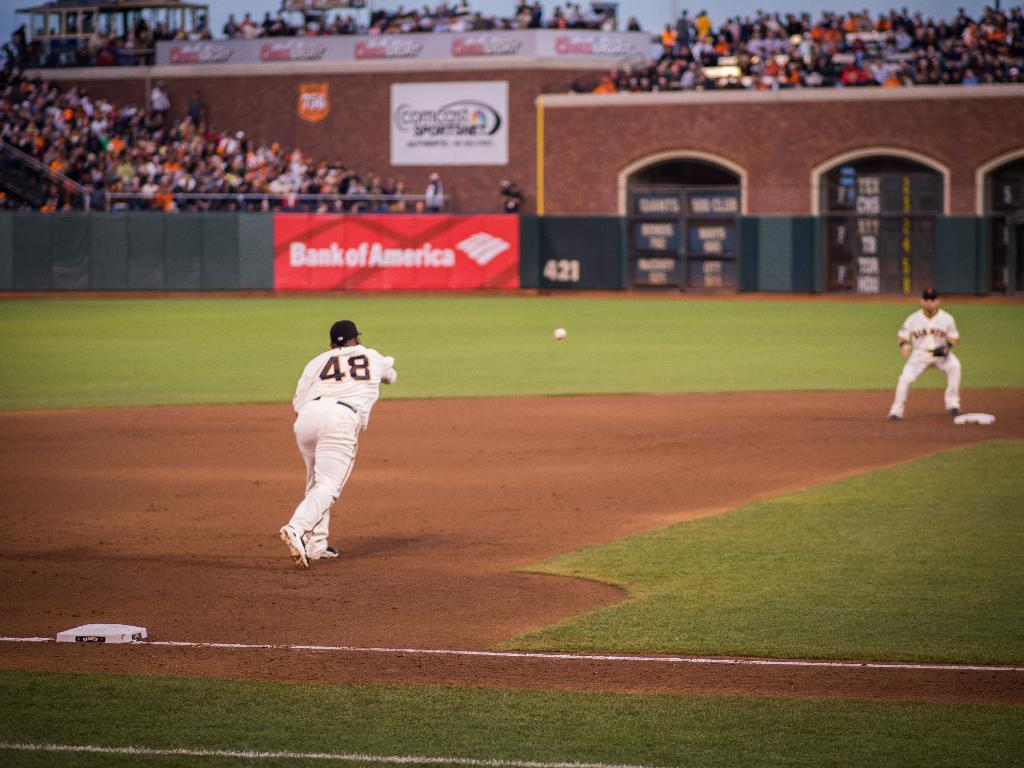<image>
Describe the image concisely. a player that is 48 throwing the ball to 2nd 